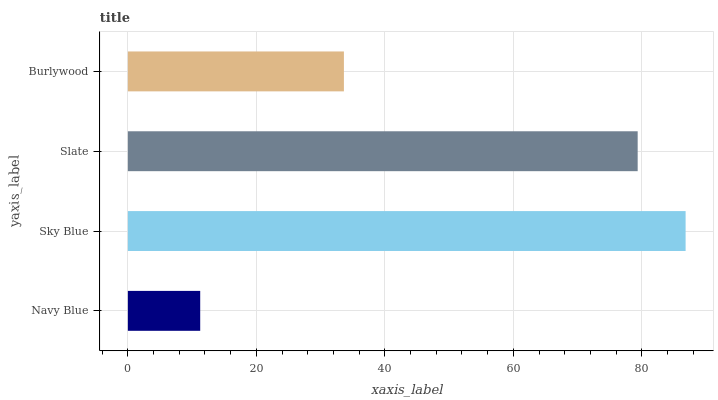Is Navy Blue the minimum?
Answer yes or no. Yes. Is Sky Blue the maximum?
Answer yes or no. Yes. Is Slate the minimum?
Answer yes or no. No. Is Slate the maximum?
Answer yes or no. No. Is Sky Blue greater than Slate?
Answer yes or no. Yes. Is Slate less than Sky Blue?
Answer yes or no. Yes. Is Slate greater than Sky Blue?
Answer yes or no. No. Is Sky Blue less than Slate?
Answer yes or no. No. Is Slate the high median?
Answer yes or no. Yes. Is Burlywood the low median?
Answer yes or no. Yes. Is Burlywood the high median?
Answer yes or no. No. Is Slate the low median?
Answer yes or no. No. 